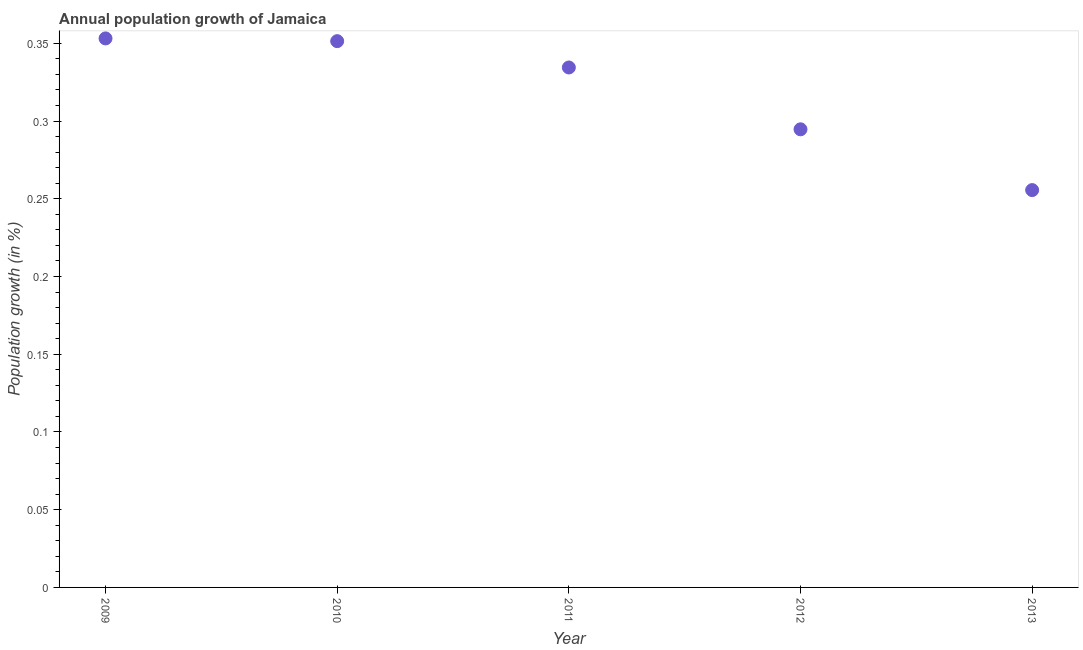What is the population growth in 2009?
Your response must be concise. 0.35. Across all years, what is the maximum population growth?
Your response must be concise. 0.35. Across all years, what is the minimum population growth?
Offer a terse response. 0.26. In which year was the population growth minimum?
Give a very brief answer. 2013. What is the sum of the population growth?
Give a very brief answer. 1.59. What is the difference between the population growth in 2009 and 2012?
Offer a terse response. 0.06. What is the average population growth per year?
Offer a terse response. 0.32. What is the median population growth?
Provide a succinct answer. 0.33. In how many years, is the population growth greater than 0.1 %?
Provide a short and direct response. 5. Do a majority of the years between 2010 and 2011 (inclusive) have population growth greater than 0.060000000000000005 %?
Keep it short and to the point. Yes. What is the ratio of the population growth in 2012 to that in 2013?
Make the answer very short. 1.15. Is the population growth in 2009 less than that in 2011?
Ensure brevity in your answer.  No. Is the difference between the population growth in 2009 and 2013 greater than the difference between any two years?
Provide a succinct answer. Yes. What is the difference between the highest and the second highest population growth?
Your response must be concise. 0. Is the sum of the population growth in 2010 and 2012 greater than the maximum population growth across all years?
Offer a very short reply. Yes. What is the difference between the highest and the lowest population growth?
Make the answer very short. 0.1. In how many years, is the population growth greater than the average population growth taken over all years?
Offer a very short reply. 3. How many dotlines are there?
Your answer should be compact. 1. How many years are there in the graph?
Your answer should be very brief. 5. What is the difference between two consecutive major ticks on the Y-axis?
Give a very brief answer. 0.05. Are the values on the major ticks of Y-axis written in scientific E-notation?
Give a very brief answer. No. Does the graph contain any zero values?
Keep it short and to the point. No. What is the title of the graph?
Your answer should be compact. Annual population growth of Jamaica. What is the label or title of the X-axis?
Your answer should be very brief. Year. What is the label or title of the Y-axis?
Your answer should be very brief. Population growth (in %). What is the Population growth (in %) in 2009?
Your response must be concise. 0.35. What is the Population growth (in %) in 2010?
Provide a short and direct response. 0.35. What is the Population growth (in %) in 2011?
Give a very brief answer. 0.33. What is the Population growth (in %) in 2012?
Provide a short and direct response. 0.29. What is the Population growth (in %) in 2013?
Offer a very short reply. 0.26. What is the difference between the Population growth (in %) in 2009 and 2010?
Keep it short and to the point. 0. What is the difference between the Population growth (in %) in 2009 and 2011?
Offer a very short reply. 0.02. What is the difference between the Population growth (in %) in 2009 and 2012?
Your answer should be very brief. 0.06. What is the difference between the Population growth (in %) in 2009 and 2013?
Ensure brevity in your answer.  0.1. What is the difference between the Population growth (in %) in 2010 and 2011?
Offer a terse response. 0.02. What is the difference between the Population growth (in %) in 2010 and 2012?
Your response must be concise. 0.06. What is the difference between the Population growth (in %) in 2010 and 2013?
Your response must be concise. 0.1. What is the difference between the Population growth (in %) in 2011 and 2012?
Your response must be concise. 0.04. What is the difference between the Population growth (in %) in 2011 and 2013?
Provide a short and direct response. 0.08. What is the difference between the Population growth (in %) in 2012 and 2013?
Keep it short and to the point. 0.04. What is the ratio of the Population growth (in %) in 2009 to that in 2011?
Ensure brevity in your answer.  1.06. What is the ratio of the Population growth (in %) in 2009 to that in 2012?
Ensure brevity in your answer.  1.2. What is the ratio of the Population growth (in %) in 2009 to that in 2013?
Provide a short and direct response. 1.38. What is the ratio of the Population growth (in %) in 2010 to that in 2011?
Provide a short and direct response. 1.05. What is the ratio of the Population growth (in %) in 2010 to that in 2012?
Offer a terse response. 1.19. What is the ratio of the Population growth (in %) in 2010 to that in 2013?
Your answer should be compact. 1.38. What is the ratio of the Population growth (in %) in 2011 to that in 2012?
Provide a succinct answer. 1.14. What is the ratio of the Population growth (in %) in 2011 to that in 2013?
Keep it short and to the point. 1.31. What is the ratio of the Population growth (in %) in 2012 to that in 2013?
Ensure brevity in your answer.  1.15. 